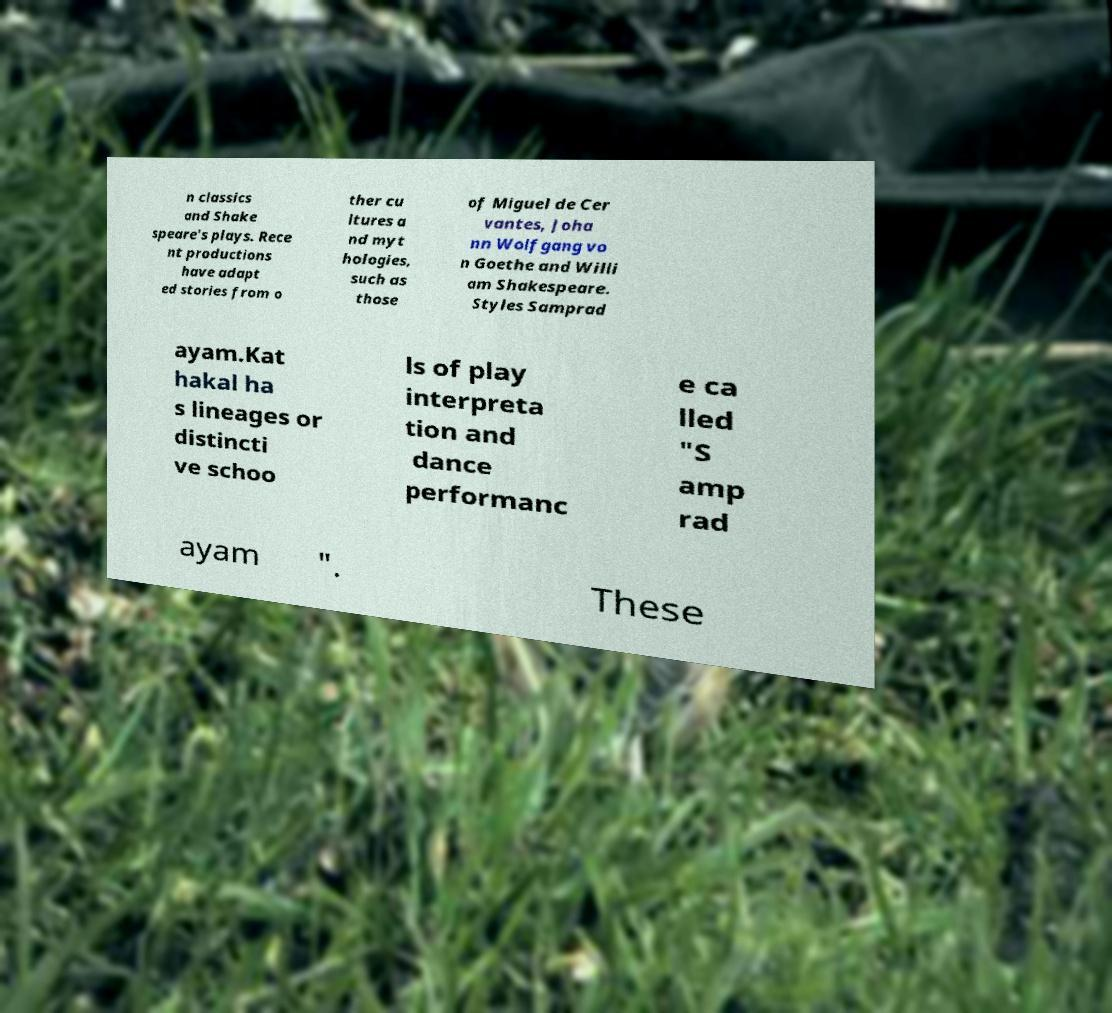Please read and relay the text visible in this image. What does it say? n classics and Shake speare's plays. Rece nt productions have adapt ed stories from o ther cu ltures a nd myt hologies, such as those of Miguel de Cer vantes, Joha nn Wolfgang vo n Goethe and Willi am Shakespeare. Styles Samprad ayam.Kat hakal ha s lineages or distincti ve schoo ls of play interpreta tion and dance performanc e ca lled "S amp rad ayam ". These 